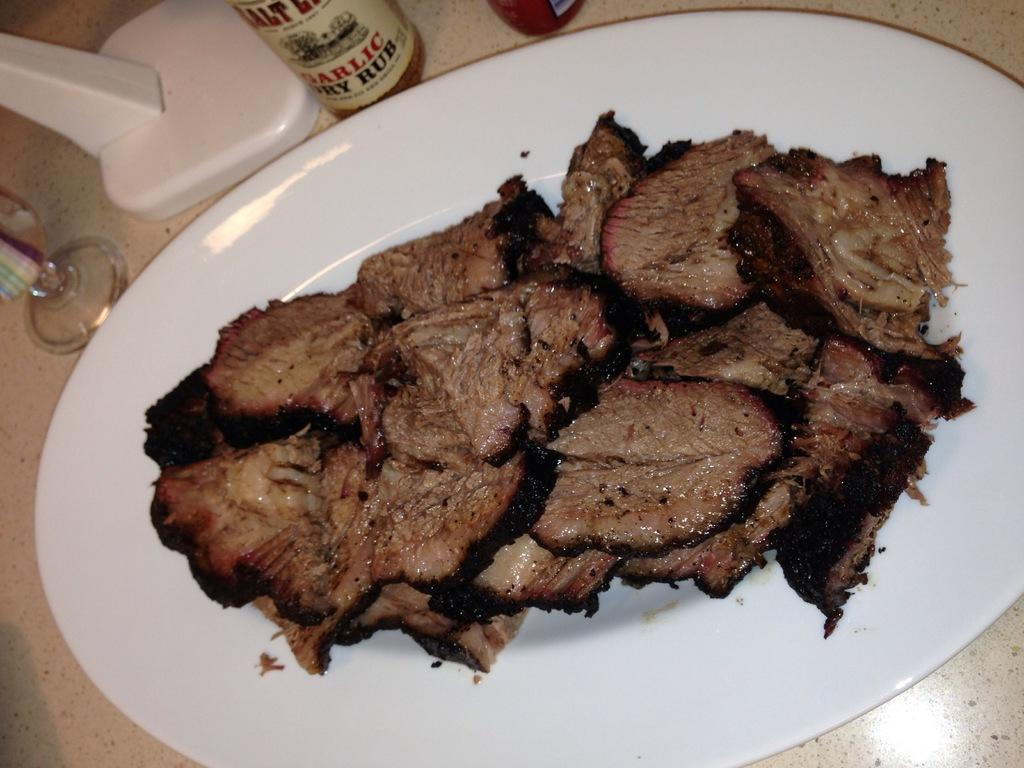<image>
Render a clear and concise summary of the photo. Plate of meat on a table next to a bottle that says "Garlic Dry Rub". 